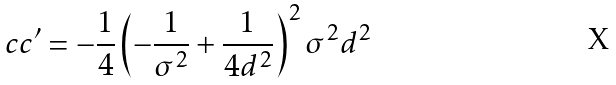<formula> <loc_0><loc_0><loc_500><loc_500>c c ^ { \prime } = - \frac { 1 } { 4 } \left ( - \frac { 1 } { \sigma ^ { 2 } } + \frac { 1 } { 4 d ^ { 2 } } \right ) ^ { 2 } \sigma ^ { 2 } d ^ { 2 }</formula> 